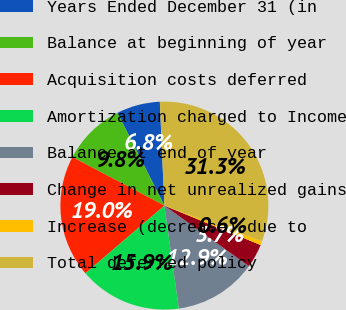<chart> <loc_0><loc_0><loc_500><loc_500><pie_chart><fcel>Years Ended December 31 (in<fcel>Balance at beginning of year<fcel>Acquisition costs deferred<fcel>Amortization charged to Income<fcel>Balance at end of year<fcel>Change in net unrealized gains<fcel>Increase (decrease) due to<fcel>Total deferred policy<nl><fcel>6.76%<fcel>9.82%<fcel>19.01%<fcel>15.95%<fcel>12.88%<fcel>3.7%<fcel>0.63%<fcel>31.26%<nl></chart> 